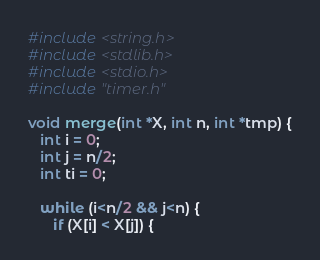Convert code to text. <code><loc_0><loc_0><loc_500><loc_500><_C_>#include <string.h>
#include <stdlib.h>
#include <stdio.h>
#include "timer.h"

void merge(int *X, int n, int *tmp) {
   int i = 0;
   int j = n/2;
   int ti = 0;

   while (i<n/2 && j<n) {
      if (X[i] < X[j]) {</code> 